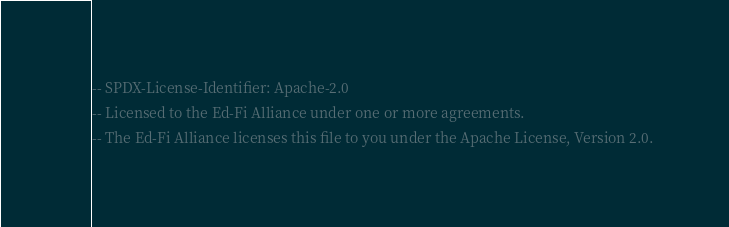Convert code to text. <code><loc_0><loc_0><loc_500><loc_500><_SQL_>-- SPDX-License-Identifier: Apache-2.0
-- Licensed to the Ed-Fi Alliance under one or more agreements.
-- The Ed-Fi Alliance licenses this file to you under the Apache License, Version 2.0.</code> 